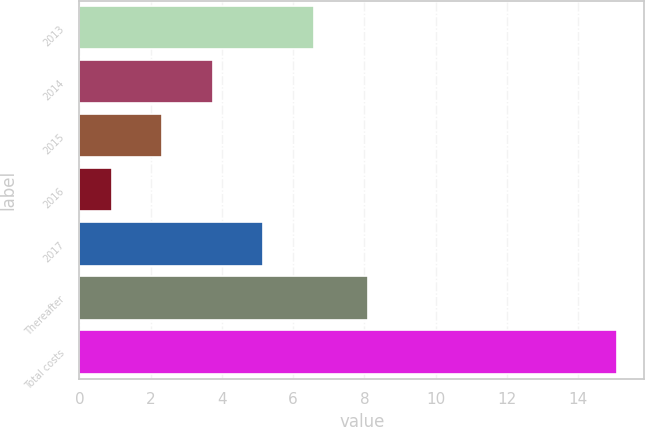Convert chart to OTSL. <chart><loc_0><loc_0><loc_500><loc_500><bar_chart><fcel>2013<fcel>2014<fcel>2015<fcel>2016<fcel>2017<fcel>Thereafter<fcel>Total costs<nl><fcel>6.58<fcel>3.74<fcel>2.32<fcel>0.9<fcel>5.16<fcel>8.1<fcel>15.1<nl></chart> 